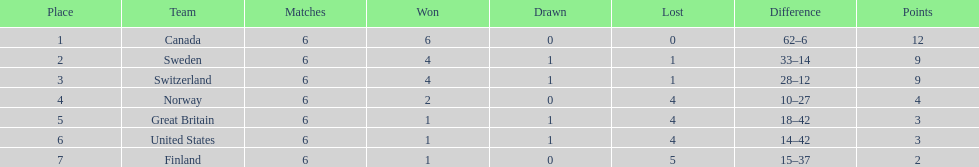Which country ended up ranking lower than the united states? Finland. 